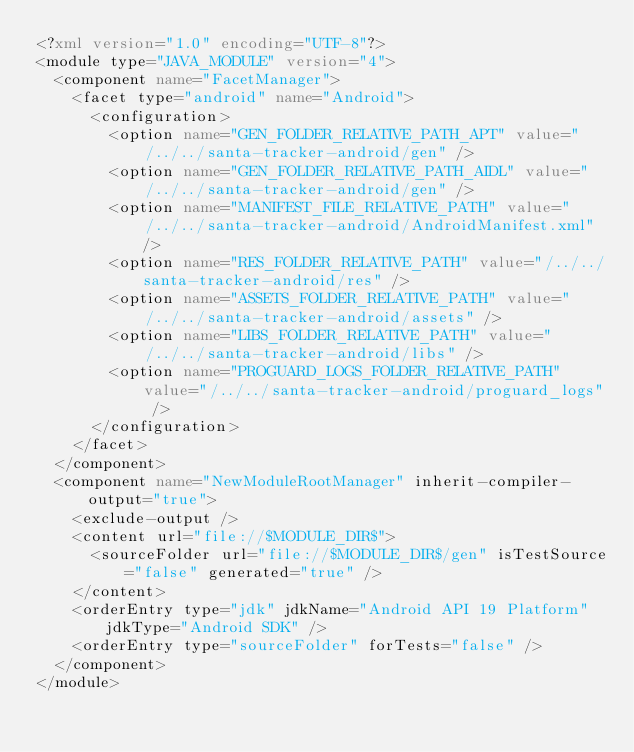<code> <loc_0><loc_0><loc_500><loc_500><_XML_><?xml version="1.0" encoding="UTF-8"?>
<module type="JAVA_MODULE" version="4">
  <component name="FacetManager">
    <facet type="android" name="Android">
      <configuration>
        <option name="GEN_FOLDER_RELATIVE_PATH_APT" value="/../../santa-tracker-android/gen" />
        <option name="GEN_FOLDER_RELATIVE_PATH_AIDL" value="/../../santa-tracker-android/gen" />
        <option name="MANIFEST_FILE_RELATIVE_PATH" value="/../../santa-tracker-android/AndroidManifest.xml" />
        <option name="RES_FOLDER_RELATIVE_PATH" value="/../../santa-tracker-android/res" />
        <option name="ASSETS_FOLDER_RELATIVE_PATH" value="/../../santa-tracker-android/assets" />
        <option name="LIBS_FOLDER_RELATIVE_PATH" value="/../../santa-tracker-android/libs" />
        <option name="PROGUARD_LOGS_FOLDER_RELATIVE_PATH" value="/../../santa-tracker-android/proguard_logs" />
      </configuration>
    </facet>
  </component>
  <component name="NewModuleRootManager" inherit-compiler-output="true">
    <exclude-output />
    <content url="file://$MODULE_DIR$">
      <sourceFolder url="file://$MODULE_DIR$/gen" isTestSource="false" generated="true" />
    </content>
    <orderEntry type="jdk" jdkName="Android API 19 Platform" jdkType="Android SDK" />
    <orderEntry type="sourceFolder" forTests="false" />
  </component>
</module></code> 